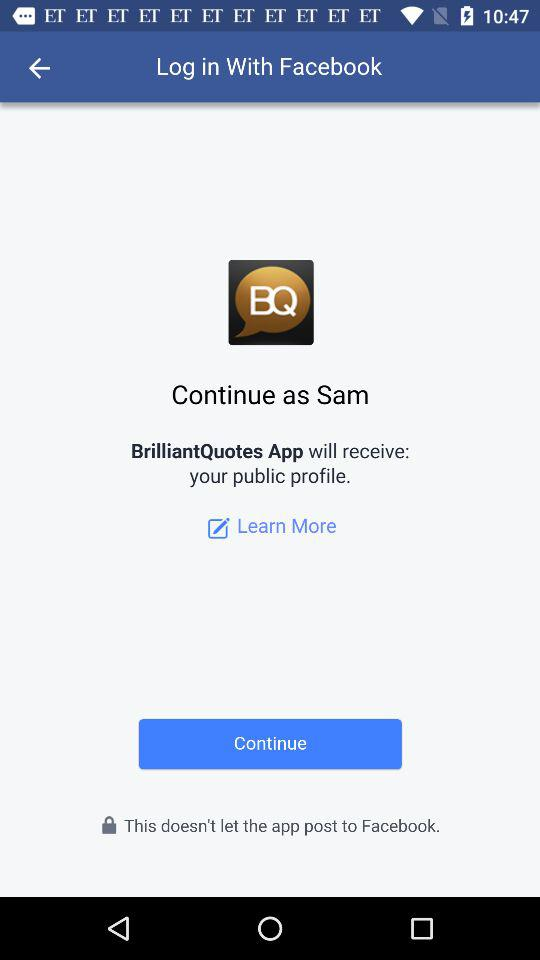Who developed "BrilliantQuotes App"?
When the provided information is insufficient, respond with <no answer>. <no answer> 